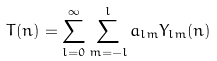<formula> <loc_0><loc_0><loc_500><loc_500>T ( n ) = \sum _ { l = 0 } ^ { \infty } \sum _ { m = - l } ^ { l } a _ { l m } Y _ { l m } ( n )</formula> 